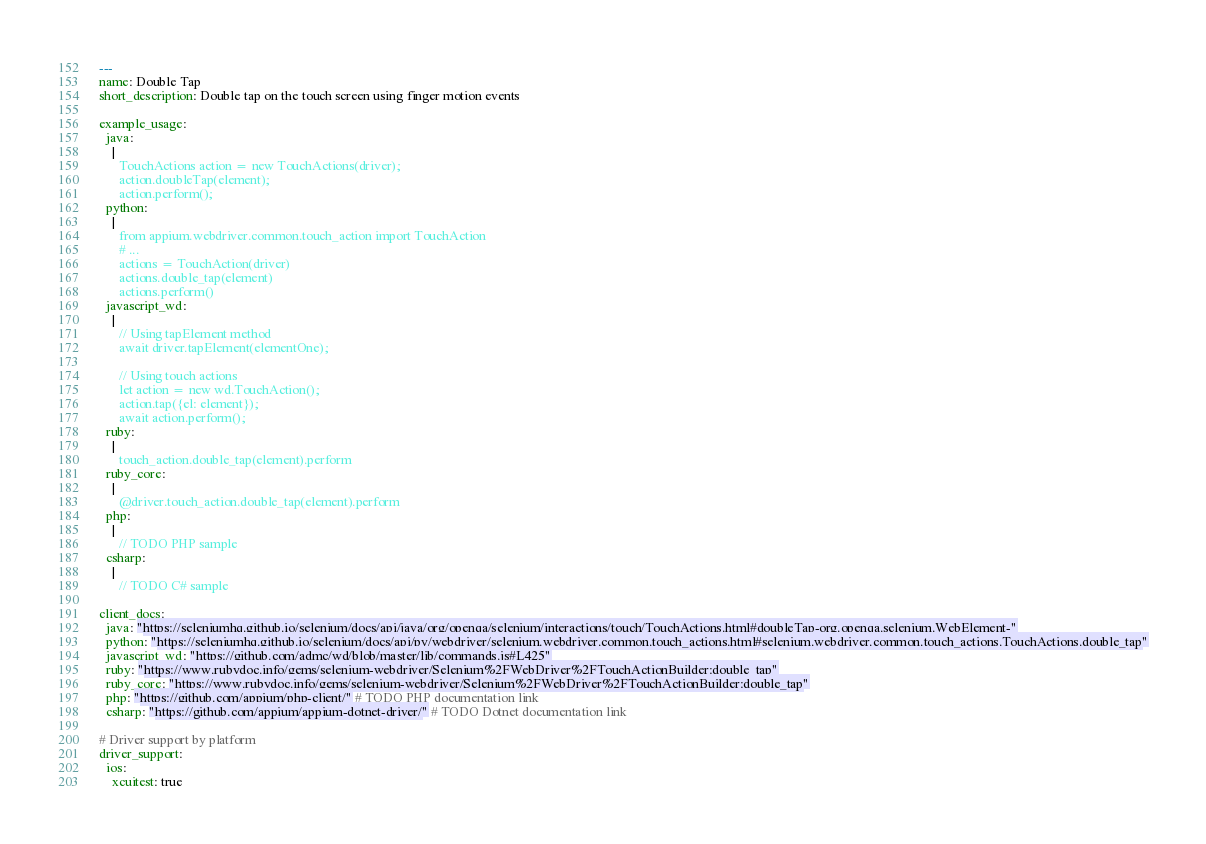<code> <loc_0><loc_0><loc_500><loc_500><_YAML_>---
name: Double Tap
short_description: Double tap on the touch screen using finger motion events

example_usage:
  java:
    |
      TouchActions action = new TouchActions(driver);
      action.doubleTap(element);
      action.perform();
  python:
    |
      from appium.webdriver.common.touch_action import TouchAction
      # ...
      actions = TouchAction(driver)
      actions.double_tap(element)
      actions.perform()
  javascript_wd:
    |
      // Using tapElement method
      await driver.tapElement(elementOne);

      // Using touch actions
      let action = new wd.TouchAction();
      action.tap({el: element});
      await action.perform();
  ruby:
    |
      touch_action.double_tap(element).perform
  ruby_core:
    |
      @driver.touch_action.double_tap(element).perform
  php:
    |
      // TODO PHP sample
  csharp:
    |
      // TODO C# sample

client_docs:
  java: "https://seleniumhq.github.io/selenium/docs/api/java/org/openqa/selenium/interactions/touch/TouchActions.html#doubleTap-org.openqa.selenium.WebElement-"
  python: "https://seleniumhq.github.io/selenium/docs/api/py/webdriver/selenium.webdriver.common.touch_actions.html#selenium.webdriver.common.touch_actions.TouchActions.double_tap"
  javascript_wd: "https://github.com/admc/wd/blob/master/lib/commands.js#L425"
  ruby: "https://www.rubydoc.info/gems/selenium-webdriver/Selenium%2FWebDriver%2FTouchActionBuilder:double_tap"
  ruby_core: "https://www.rubydoc.info/gems/selenium-webdriver/Selenium%2FWebDriver%2FTouchActionBuilder:double_tap"
  php: "https://github.com/appium/php-client/" # TODO PHP documentation link
  csharp: "https://github.com/appium/appium-dotnet-driver/" # TODO Dotnet documentation link

# Driver support by platform
driver_support:
  ios:
    xcuitest: true</code> 